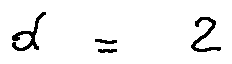<formula> <loc_0><loc_0><loc_500><loc_500>d = 2</formula> 